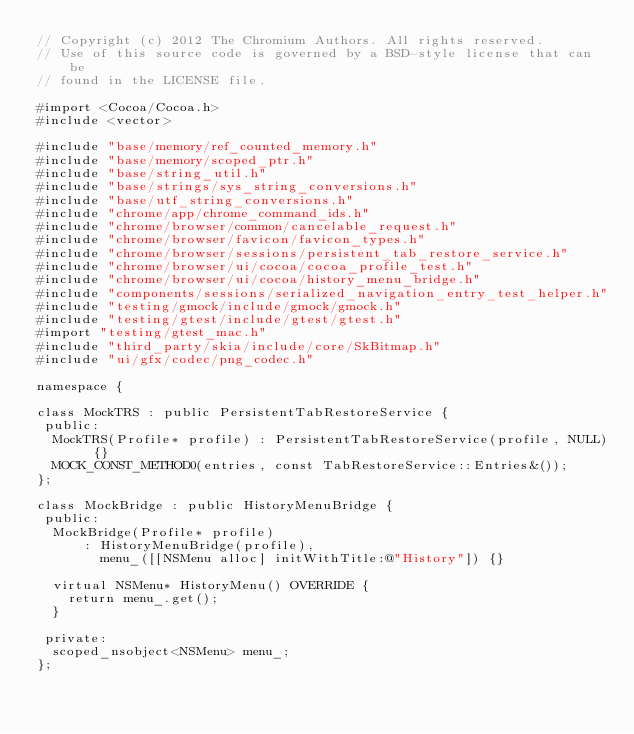<code> <loc_0><loc_0><loc_500><loc_500><_ObjectiveC_>// Copyright (c) 2012 The Chromium Authors. All rights reserved.
// Use of this source code is governed by a BSD-style license that can be
// found in the LICENSE file.

#import <Cocoa/Cocoa.h>
#include <vector>

#include "base/memory/ref_counted_memory.h"
#include "base/memory/scoped_ptr.h"
#include "base/string_util.h"
#include "base/strings/sys_string_conversions.h"
#include "base/utf_string_conversions.h"
#include "chrome/app/chrome_command_ids.h"
#include "chrome/browser/common/cancelable_request.h"
#include "chrome/browser/favicon/favicon_types.h"
#include "chrome/browser/sessions/persistent_tab_restore_service.h"
#include "chrome/browser/ui/cocoa/cocoa_profile_test.h"
#include "chrome/browser/ui/cocoa/history_menu_bridge.h"
#include "components/sessions/serialized_navigation_entry_test_helper.h"
#include "testing/gmock/include/gmock/gmock.h"
#include "testing/gtest/include/gtest/gtest.h"
#import "testing/gtest_mac.h"
#include "third_party/skia/include/core/SkBitmap.h"
#include "ui/gfx/codec/png_codec.h"

namespace {

class MockTRS : public PersistentTabRestoreService {
 public:
  MockTRS(Profile* profile) : PersistentTabRestoreService(profile, NULL) {}
  MOCK_CONST_METHOD0(entries, const TabRestoreService::Entries&());
};

class MockBridge : public HistoryMenuBridge {
 public:
  MockBridge(Profile* profile)
      : HistoryMenuBridge(profile),
        menu_([[NSMenu alloc] initWithTitle:@"History"]) {}

  virtual NSMenu* HistoryMenu() OVERRIDE {
    return menu_.get();
  }

 private:
  scoped_nsobject<NSMenu> menu_;
};
</code> 